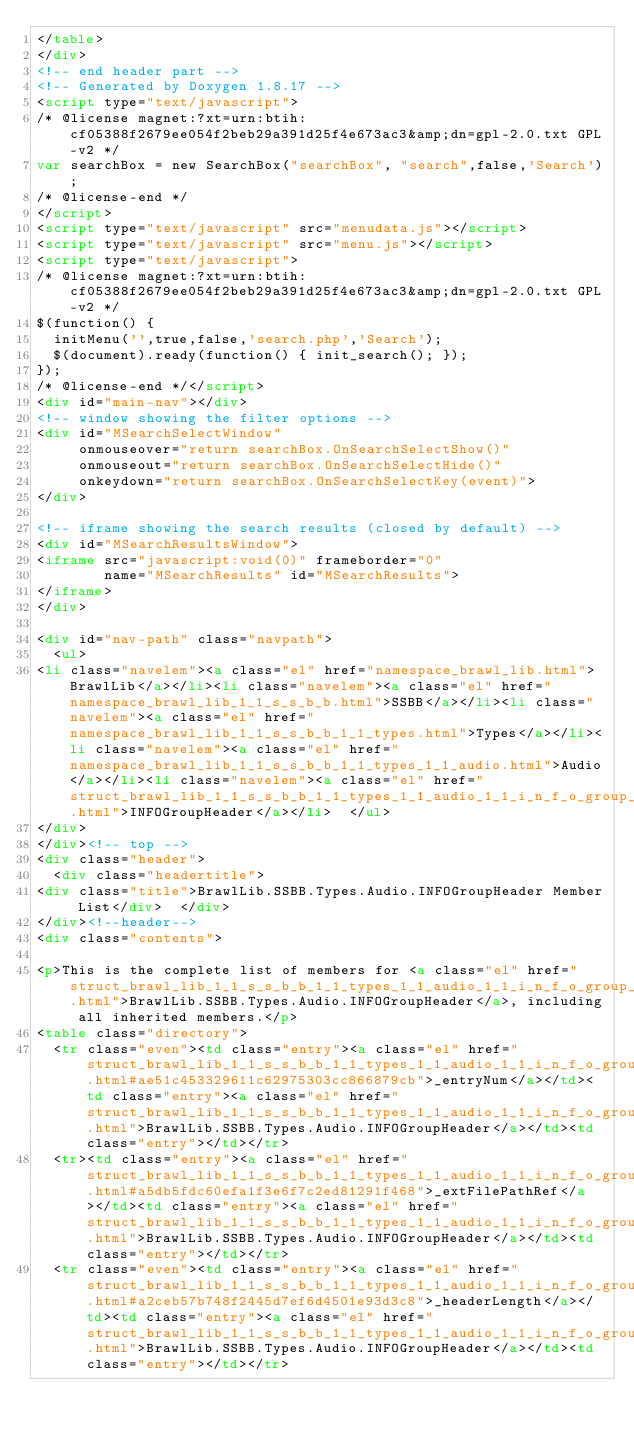<code> <loc_0><loc_0><loc_500><loc_500><_HTML_></table>
</div>
<!-- end header part -->
<!-- Generated by Doxygen 1.8.17 -->
<script type="text/javascript">
/* @license magnet:?xt=urn:btih:cf05388f2679ee054f2beb29a391d25f4e673ac3&amp;dn=gpl-2.0.txt GPL-v2 */
var searchBox = new SearchBox("searchBox", "search",false,'Search');
/* @license-end */
</script>
<script type="text/javascript" src="menudata.js"></script>
<script type="text/javascript" src="menu.js"></script>
<script type="text/javascript">
/* @license magnet:?xt=urn:btih:cf05388f2679ee054f2beb29a391d25f4e673ac3&amp;dn=gpl-2.0.txt GPL-v2 */
$(function() {
  initMenu('',true,false,'search.php','Search');
  $(document).ready(function() { init_search(); });
});
/* @license-end */</script>
<div id="main-nav"></div>
<!-- window showing the filter options -->
<div id="MSearchSelectWindow"
     onmouseover="return searchBox.OnSearchSelectShow()"
     onmouseout="return searchBox.OnSearchSelectHide()"
     onkeydown="return searchBox.OnSearchSelectKey(event)">
</div>

<!-- iframe showing the search results (closed by default) -->
<div id="MSearchResultsWindow">
<iframe src="javascript:void(0)" frameborder="0" 
        name="MSearchResults" id="MSearchResults">
</iframe>
</div>

<div id="nav-path" class="navpath">
  <ul>
<li class="navelem"><a class="el" href="namespace_brawl_lib.html">BrawlLib</a></li><li class="navelem"><a class="el" href="namespace_brawl_lib_1_1_s_s_b_b.html">SSBB</a></li><li class="navelem"><a class="el" href="namespace_brawl_lib_1_1_s_s_b_b_1_1_types.html">Types</a></li><li class="navelem"><a class="el" href="namespace_brawl_lib_1_1_s_s_b_b_1_1_types_1_1_audio.html">Audio</a></li><li class="navelem"><a class="el" href="struct_brawl_lib_1_1_s_s_b_b_1_1_types_1_1_audio_1_1_i_n_f_o_group_header.html">INFOGroupHeader</a></li>  </ul>
</div>
</div><!-- top -->
<div class="header">
  <div class="headertitle">
<div class="title">BrawlLib.SSBB.Types.Audio.INFOGroupHeader Member List</div>  </div>
</div><!--header-->
<div class="contents">

<p>This is the complete list of members for <a class="el" href="struct_brawl_lib_1_1_s_s_b_b_1_1_types_1_1_audio_1_1_i_n_f_o_group_header.html">BrawlLib.SSBB.Types.Audio.INFOGroupHeader</a>, including all inherited members.</p>
<table class="directory">
  <tr class="even"><td class="entry"><a class="el" href="struct_brawl_lib_1_1_s_s_b_b_1_1_types_1_1_audio_1_1_i_n_f_o_group_header.html#ae51c453329611c62975303cc866879cb">_entryNum</a></td><td class="entry"><a class="el" href="struct_brawl_lib_1_1_s_s_b_b_1_1_types_1_1_audio_1_1_i_n_f_o_group_header.html">BrawlLib.SSBB.Types.Audio.INFOGroupHeader</a></td><td class="entry"></td></tr>
  <tr><td class="entry"><a class="el" href="struct_brawl_lib_1_1_s_s_b_b_1_1_types_1_1_audio_1_1_i_n_f_o_group_header.html#a5db5fdc60efa1f3e6f7c2ed81291f468">_extFilePathRef</a></td><td class="entry"><a class="el" href="struct_brawl_lib_1_1_s_s_b_b_1_1_types_1_1_audio_1_1_i_n_f_o_group_header.html">BrawlLib.SSBB.Types.Audio.INFOGroupHeader</a></td><td class="entry"></td></tr>
  <tr class="even"><td class="entry"><a class="el" href="struct_brawl_lib_1_1_s_s_b_b_1_1_types_1_1_audio_1_1_i_n_f_o_group_header.html#a2ceb57b748f2445d7ef6d4501e93d3c8">_headerLength</a></td><td class="entry"><a class="el" href="struct_brawl_lib_1_1_s_s_b_b_1_1_types_1_1_audio_1_1_i_n_f_o_group_header.html">BrawlLib.SSBB.Types.Audio.INFOGroupHeader</a></td><td class="entry"></td></tr></code> 